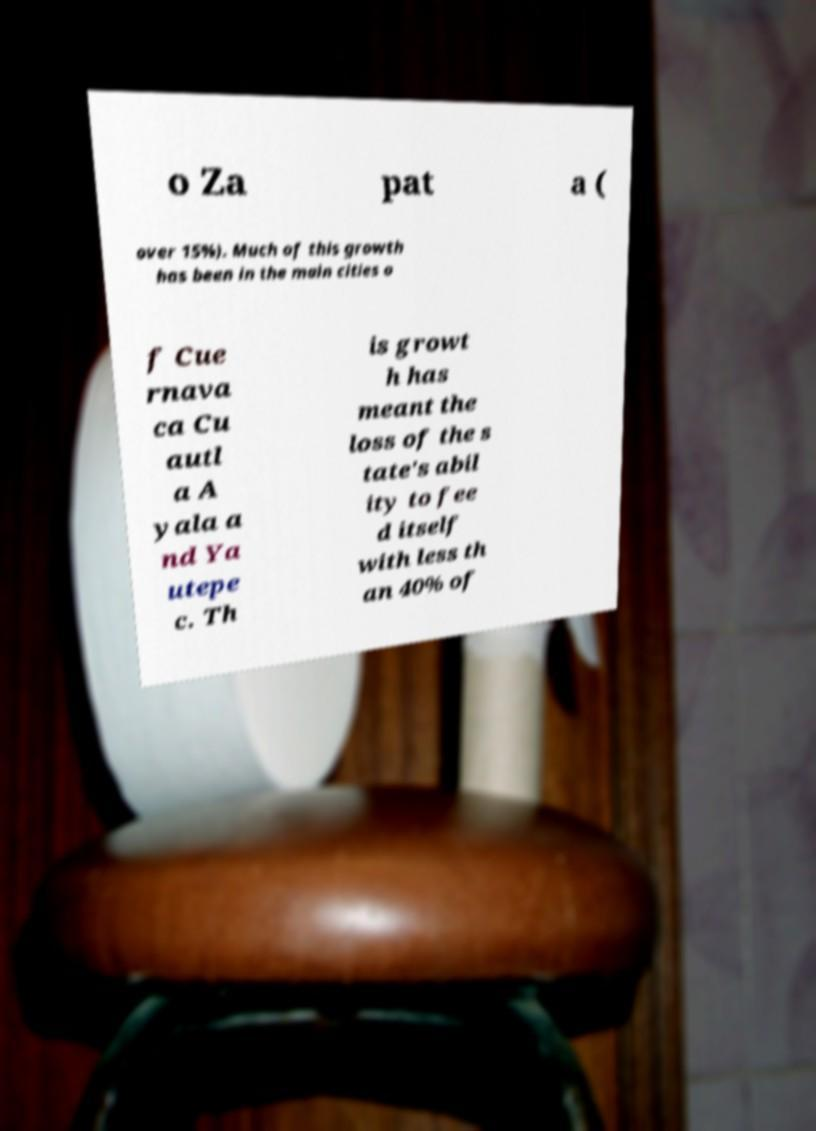Please read and relay the text visible in this image. What does it say? o Za pat a ( over 15%). Much of this growth has been in the main cities o f Cue rnava ca Cu autl a A yala a nd Ya utepe c. Th is growt h has meant the loss of the s tate's abil ity to fee d itself with less th an 40% of 